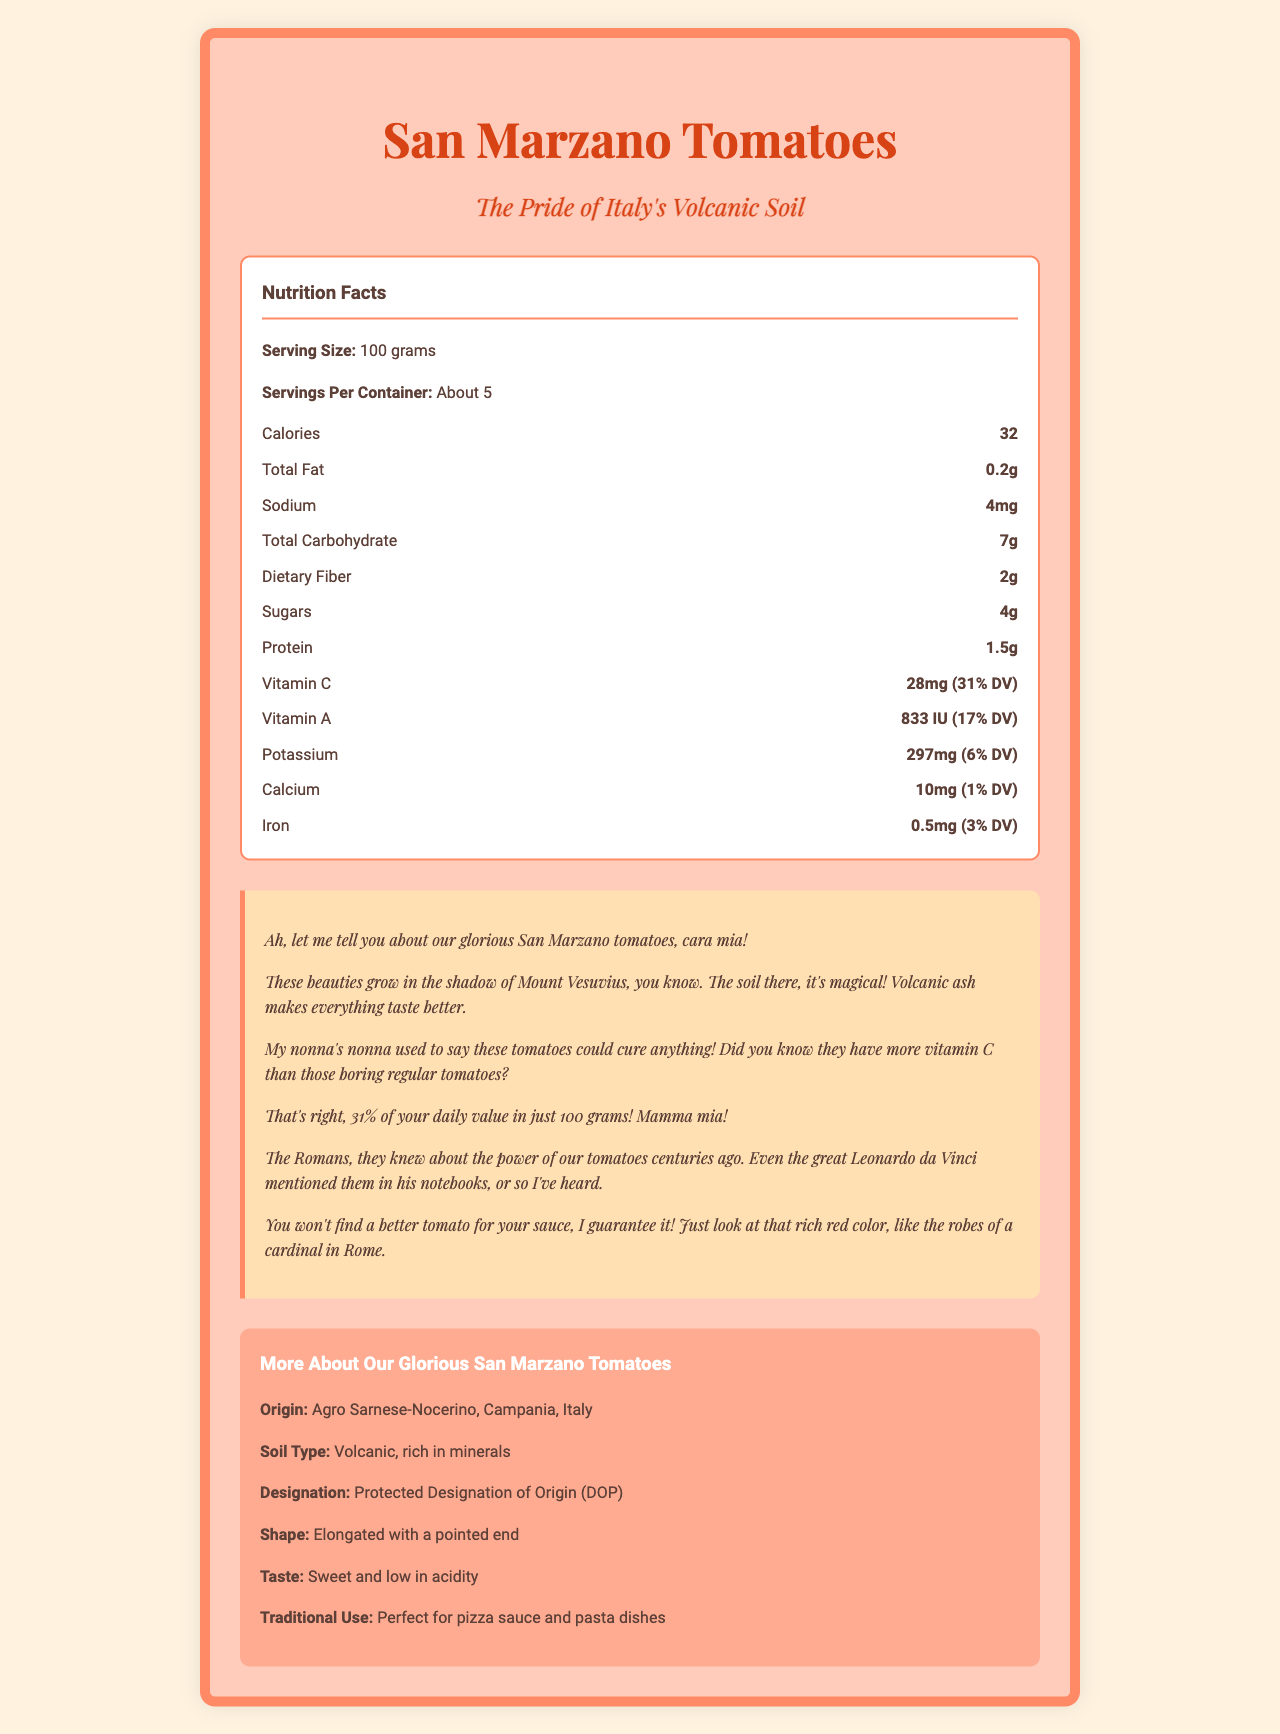what is the serving size for San Marzano tomatoes? The document states the serving size as 100 grams in the "Nutrition Facts" section.
Answer: 100 grams how many calories are in one serving of San Marzano tomatoes? The document lists 32 calories per serving in the "Nutrition Facts" section.
Answer: 32 how much vitamin C is in a serving of San Marzano tomatoes? The document specifies 28mg of vitamin C per serving, which is 31% of the daily value, in the "Nutrition Facts" section.
Answer: 28mg (31% DV) what is the total fat content in a serving? The document states that the total fat content per serving is 0.2 grams in the "Nutrition Facts" section.
Answer: 0.2g how much protein is present in a serving of these tomatoes? The document shows that there are 1.5 grams of protein per serving in the "Nutrition Facts" section.
Answer: 1.5g what is the sodium content in each serving of San Marzano tomatoes? A. 2mg B. 4mg C. 8mg D. 10mg The document lists the sodium content as 4mg per serving in the "Nutrition Facts" section.
Answer: B which of the following nutrients is NOT listed in the nutrition facts? I. Magnesium II. Potassium III. Fiber IV. Calcium The document does not list magnesium in the "Nutrition Facts" section.
Answer: I are San Marzano tomatoes low in fat? The document indicates a total fat content of 0.2g per serving, which is considered low.
Answer: Yes explain the origin and soil type of San Marzano tomatoes. The "More About Our Glorious San Marzano Tomatoes" section in the document specifies that these tomatoes are from Agro Sarnese-Nocerino, Campania, Italy, and that the soil type is volcanic and rich in minerals.
Answer: The San Marzano tomatoes originate from the Agro Sarnese-Nocerino area in Campania, Italy, and grow in volcanic soil rich in minerals. what makes San Marzano tomatoes unique according to the storytelling section? The document describes several unique aspects of San Marzano tomatoes, including their growth near Mount Vesuvius, their high vitamin C content, their superior taste due to the volcanic soil, and their vibrant red color in the "Storytelling" section.
Answer: They grow in the shadow of Mount Vesuvius, have more vitamin C than regular tomatoes, and are praised for their superior taste and rich red color. what is the daily value percentage of vitamin A in a serving? The document lists the vitamin A content per serving as 833 IU, which is 17% of the daily value, in the "Nutrition Facts" section.
Answer: 17% what are some traditional uses of San Marzano tomatoes? The "More About Our Glorious San Marzano Tomatoes" section mentions that San Marzano tomatoes are traditionally used for pizza sauce and pasta dishes.
Answer: Perfect for pizza sauce and pasta dishes how would you summarize the entire document? The document effectively combines nutrition facts, origin details, and storytelling to showcase the superior qualities and traditional uses of San Marzano tomatoes grown in volcanic soil.
Answer: The document provides detailed information about San Marzano tomatoes, including their nutritional facts, origin, and unique characteristics attributed to the volcanic soil near Mount Vesuvius. It highlights their high vitamin C content and traditional culinary uses, particularly for pizza sauce and pasta dishes. The storytelling section adds historical and cultural context to their superior taste and quality. what is the percentage of the daily value for dietary fiber in a serving? The document lists the amount of dietary fiber per serving as 2 grams but does not provide the percentage of the daily value.
Answer: Not enough information where did the great Leonardo da Vinci mention San Marzano tomatoes in his notebooks? The document says that Leonardo da Vinci mentioned San Marzano tomatoes in his notebooks, but it does not provide the specific location or details in the notebooks.
Answer: Cannot be determined 